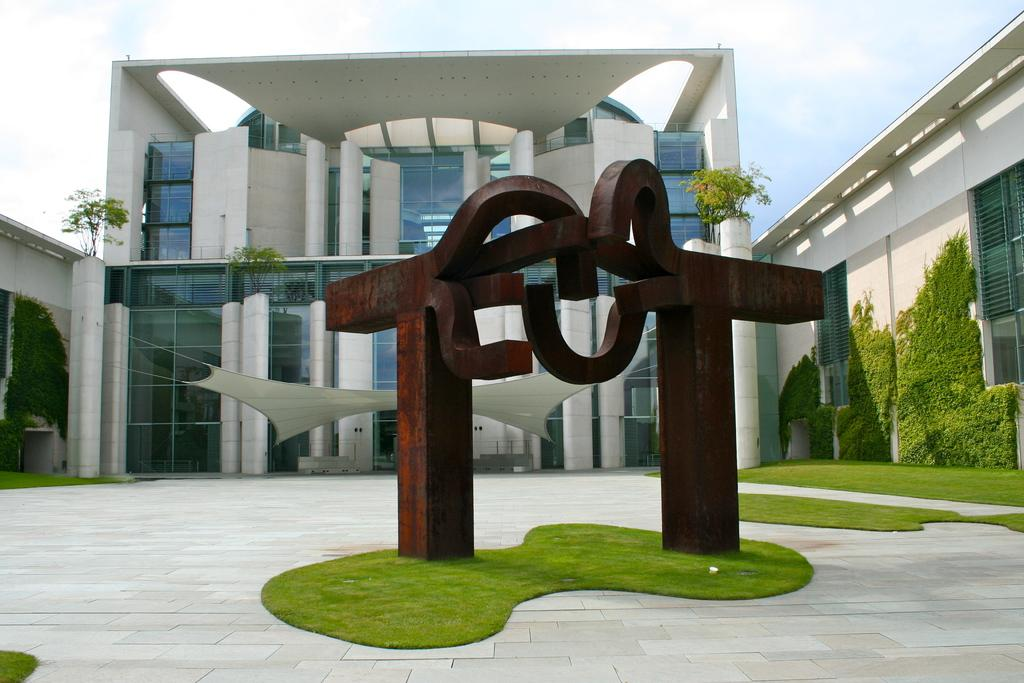What is located on the grass in the image? There is a sculpture on the grass. What type of shelter is present in the image? There is a tent in the image. What type of structure can be seen in the image? There is a building in the image. What feature of the building is mentioned in the facts? The building has windows. What type of natural elements are present in the image? There are plants in the image. What architectural feature is mentioned in the facts? There are pillars in the image. What other objects can be seen in the image? There are other objects in the image, but their specific details are not mentioned in the facts. What is visible in the background of the image? The sky is visible in the background, and there are clouds in the sky. How many muscles can be seen flexing on the sculpture in the image? There is no mention of muscles on the sculpture in the image, so it cannot be determined from the facts. What type of umbrella is being used to protect the plants from the sun in the image? There is no umbrella present in the image, so it cannot be determined from the facts. 